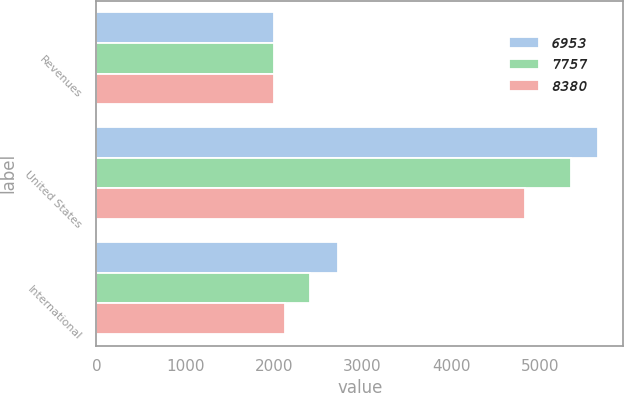Convert chart to OTSL. <chart><loc_0><loc_0><loc_500><loc_500><stacked_bar_chart><ecel><fcel>Revenues<fcel>United States<fcel>International<nl><fcel>6953<fcel>2003<fcel>5655<fcel>2725<nl><fcel>7757<fcel>2002<fcel>5347<fcel>2410<nl><fcel>8380<fcel>2001<fcel>4827<fcel>2126<nl></chart> 